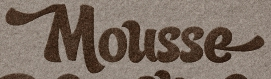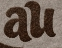Transcribe the words shown in these images in order, separated by a semicolon. Mousse; au 